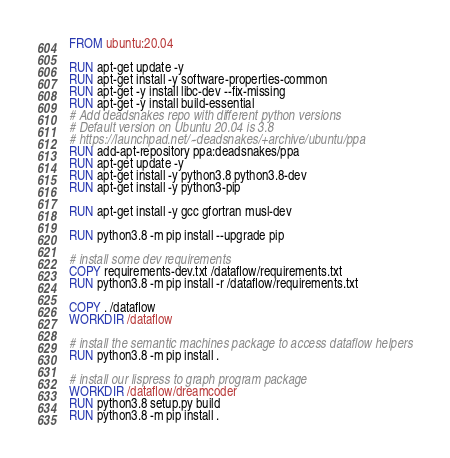<code> <loc_0><loc_0><loc_500><loc_500><_Dockerfile_>FROM ubuntu:20.04

RUN apt-get update -y
RUN apt-get install -y software-properties-common
RUN apt-get -y install libc-dev --fix-missing
RUN apt-get -y install build-essential
# Add deadsnakes repo with different python versions
# Default version on Ubuntu 20.04 is 3.8
# https://launchpad.net/~deadsnakes/+archive/ubuntu/ppa
RUN add-apt-repository ppa:deadsnakes/ppa
RUN apt-get update -y
RUN apt-get install -y python3.8 python3.8-dev 
RUN apt-get install -y python3-pip

RUN apt-get install -y gcc gfortran musl-dev

RUN python3.8 -m pip install --upgrade pip

# install some dev requirements
COPY requirements-dev.txt /dataflow/requirements.txt
RUN python3.8 -m pip install -r /dataflow/requirements.txt

COPY . /dataflow
WORKDIR /dataflow

# install the semantic machines package to access dataflow helpers
RUN python3.8 -m pip install .

# install our lispress to graph program package
WORKDIR /dataflow/dreamcoder
RUN python3.8 setup.py build
RUN python3.8 -m pip install .</code> 